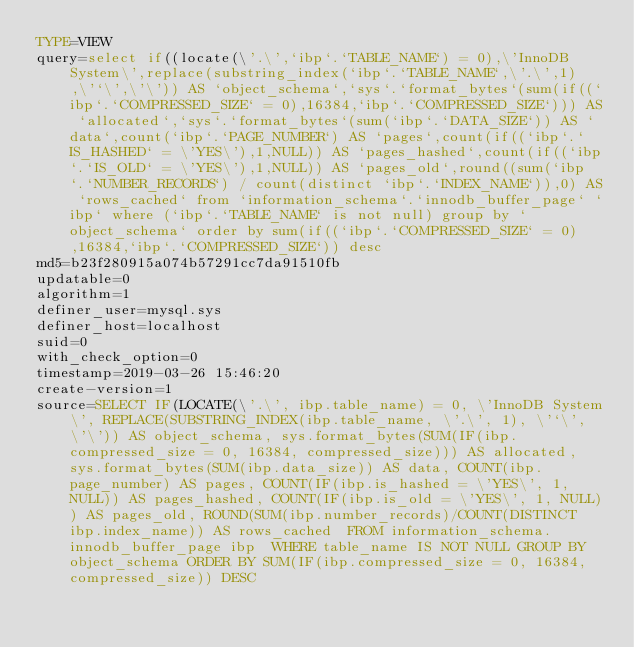<code> <loc_0><loc_0><loc_500><loc_500><_VisualBasic_>TYPE=VIEW
query=select if((locate(\'.\',`ibp`.`TABLE_NAME`) = 0),\'InnoDB System\',replace(substring_index(`ibp`.`TABLE_NAME`,\'.\',1),\'`\',\'\')) AS `object_schema`,`sys`.`format_bytes`(sum(if((`ibp`.`COMPRESSED_SIZE` = 0),16384,`ibp`.`COMPRESSED_SIZE`))) AS `allocated`,`sys`.`format_bytes`(sum(`ibp`.`DATA_SIZE`)) AS `data`,count(`ibp`.`PAGE_NUMBER`) AS `pages`,count(if((`ibp`.`IS_HASHED` = \'YES\'),1,NULL)) AS `pages_hashed`,count(if((`ibp`.`IS_OLD` = \'YES\'),1,NULL)) AS `pages_old`,round((sum(`ibp`.`NUMBER_RECORDS`) / count(distinct `ibp`.`INDEX_NAME`)),0) AS `rows_cached` from `information_schema`.`innodb_buffer_page` `ibp` where (`ibp`.`TABLE_NAME` is not null) group by `object_schema` order by sum(if((`ibp`.`COMPRESSED_SIZE` = 0),16384,`ibp`.`COMPRESSED_SIZE`)) desc
md5=b23f280915a074b57291cc7da91510fb
updatable=0
algorithm=1
definer_user=mysql.sys
definer_host=localhost
suid=0
with_check_option=0
timestamp=2019-03-26 15:46:20
create-version=1
source=SELECT IF(LOCATE(\'.\', ibp.table_name) = 0, \'InnoDB System\', REPLACE(SUBSTRING_INDEX(ibp.table_name, \'.\', 1), \'`\', \'\')) AS object_schema, sys.format_bytes(SUM(IF(ibp.compressed_size = 0, 16384, compressed_size))) AS allocated, sys.format_bytes(SUM(ibp.data_size)) AS data, COUNT(ibp.page_number) AS pages, COUNT(IF(ibp.is_hashed = \'YES\', 1, NULL)) AS pages_hashed, COUNT(IF(ibp.is_old = \'YES\', 1, NULL)) AS pages_old, ROUND(SUM(ibp.number_records)/COUNT(DISTINCT ibp.index_name)) AS rows_cached  FROM information_schema.innodb_buffer_page ibp  WHERE table_name IS NOT NULL GROUP BY object_schema ORDER BY SUM(IF(ibp.compressed_size = 0, 16384, compressed_size)) DESC</code> 